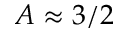<formula> <loc_0><loc_0><loc_500><loc_500>A \approx 3 / 2</formula> 